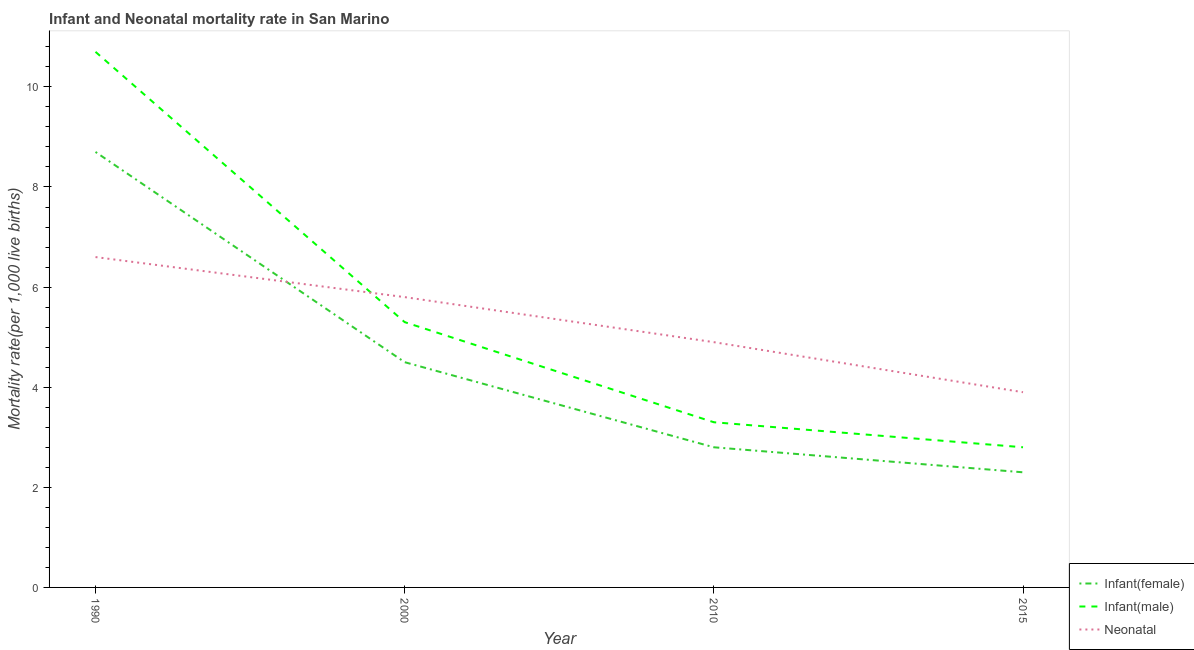What is the neonatal mortality rate in 2015?
Offer a very short reply. 3.9. Across all years, what is the minimum infant mortality rate(female)?
Provide a succinct answer. 2.3. In which year was the neonatal mortality rate maximum?
Make the answer very short. 1990. In which year was the infant mortality rate(male) minimum?
Provide a succinct answer. 2015. What is the total infant mortality rate(female) in the graph?
Provide a short and direct response. 18.3. What is the difference between the neonatal mortality rate in 1990 and that in 2000?
Provide a short and direct response. 0.8. What is the difference between the infant mortality rate(male) in 2015 and the neonatal mortality rate in 2000?
Your answer should be compact. -3. What is the average neonatal mortality rate per year?
Offer a terse response. 5.3. In the year 2000, what is the difference between the infant mortality rate(male) and infant mortality rate(female)?
Provide a succinct answer. 0.8. In how many years, is the infant mortality rate(female) greater than 8?
Your answer should be very brief. 1. What is the ratio of the infant mortality rate(male) in 2010 to that in 2015?
Offer a very short reply. 1.18. Is the infant mortality rate(female) in 1990 less than that in 2000?
Your answer should be compact. No. Is the difference between the infant mortality rate(female) in 1990 and 2000 greater than the difference between the neonatal mortality rate in 1990 and 2000?
Keep it short and to the point. Yes. What is the difference between the highest and the second highest infant mortality rate(female)?
Your answer should be very brief. 4.2. What is the difference between the highest and the lowest infant mortality rate(female)?
Ensure brevity in your answer.  6.4. Does the neonatal mortality rate monotonically increase over the years?
Your response must be concise. No. Is the neonatal mortality rate strictly greater than the infant mortality rate(male) over the years?
Your answer should be compact. No. How many lines are there?
Make the answer very short. 3. Does the graph contain grids?
Your answer should be very brief. No. Where does the legend appear in the graph?
Give a very brief answer. Bottom right. How many legend labels are there?
Make the answer very short. 3. What is the title of the graph?
Offer a very short reply. Infant and Neonatal mortality rate in San Marino. Does "Central government" appear as one of the legend labels in the graph?
Offer a terse response. No. What is the label or title of the Y-axis?
Provide a short and direct response. Mortality rate(per 1,0 live births). What is the Mortality rate(per 1,000 live births) of Infant(female) in 1990?
Provide a succinct answer. 8.7. What is the Mortality rate(per 1,000 live births) of Infant(female) in 2010?
Your response must be concise. 2.8. What is the Mortality rate(per 1,000 live births) in Infant(male) in 2010?
Provide a short and direct response. 3.3. What is the Mortality rate(per 1,000 live births) of Neonatal  in 2010?
Offer a terse response. 4.9. What is the Mortality rate(per 1,000 live births) in Infant(female) in 2015?
Ensure brevity in your answer.  2.3. What is the Mortality rate(per 1,000 live births) in Infant(male) in 2015?
Provide a short and direct response. 2.8. Across all years, what is the maximum Mortality rate(per 1,000 live births) of Infant(male)?
Ensure brevity in your answer.  10.7. Across all years, what is the maximum Mortality rate(per 1,000 live births) of Neonatal ?
Offer a very short reply. 6.6. Across all years, what is the minimum Mortality rate(per 1,000 live births) in Infant(female)?
Give a very brief answer. 2.3. Across all years, what is the minimum Mortality rate(per 1,000 live births) in Infant(male)?
Your response must be concise. 2.8. What is the total Mortality rate(per 1,000 live births) in Infant(female) in the graph?
Your answer should be compact. 18.3. What is the total Mortality rate(per 1,000 live births) in Infant(male) in the graph?
Give a very brief answer. 22.1. What is the total Mortality rate(per 1,000 live births) in Neonatal  in the graph?
Ensure brevity in your answer.  21.2. What is the difference between the Mortality rate(per 1,000 live births) of Infant(female) in 1990 and that in 2000?
Your answer should be compact. 4.2. What is the difference between the Mortality rate(per 1,000 live births) of Infant(female) in 1990 and that in 2010?
Your response must be concise. 5.9. What is the difference between the Mortality rate(per 1,000 live births) of Neonatal  in 1990 and that in 2010?
Keep it short and to the point. 1.7. What is the difference between the Mortality rate(per 1,000 live births) of Infant(male) in 1990 and that in 2015?
Ensure brevity in your answer.  7.9. What is the difference between the Mortality rate(per 1,000 live births) of Infant(female) in 2000 and that in 2010?
Your answer should be compact. 1.7. What is the difference between the Mortality rate(per 1,000 live births) in Infant(male) in 2000 and that in 2010?
Keep it short and to the point. 2. What is the difference between the Mortality rate(per 1,000 live births) in Infant(female) in 2010 and that in 2015?
Provide a short and direct response. 0.5. What is the difference between the Mortality rate(per 1,000 live births) of Infant(male) in 2010 and that in 2015?
Make the answer very short. 0.5. What is the difference between the Mortality rate(per 1,000 live births) of Neonatal  in 2010 and that in 2015?
Make the answer very short. 1. What is the difference between the Mortality rate(per 1,000 live births) in Infant(female) in 1990 and the Mortality rate(per 1,000 live births) in Infant(male) in 2000?
Keep it short and to the point. 3.4. What is the difference between the Mortality rate(per 1,000 live births) in Infant(female) in 1990 and the Mortality rate(per 1,000 live births) in Infant(male) in 2010?
Provide a succinct answer. 5.4. What is the difference between the Mortality rate(per 1,000 live births) of Infant(female) in 1990 and the Mortality rate(per 1,000 live births) of Infant(male) in 2015?
Your response must be concise. 5.9. What is the difference between the Mortality rate(per 1,000 live births) of Infant(male) in 1990 and the Mortality rate(per 1,000 live births) of Neonatal  in 2015?
Offer a terse response. 6.8. What is the difference between the Mortality rate(per 1,000 live births) in Infant(female) in 2000 and the Mortality rate(per 1,000 live births) in Infant(male) in 2010?
Give a very brief answer. 1.2. What is the difference between the Mortality rate(per 1,000 live births) in Infant(female) in 2000 and the Mortality rate(per 1,000 live births) in Neonatal  in 2010?
Provide a succinct answer. -0.4. What is the difference between the Mortality rate(per 1,000 live births) in Infant(female) in 2000 and the Mortality rate(per 1,000 live births) in Infant(male) in 2015?
Your response must be concise. 1.7. What is the difference between the Mortality rate(per 1,000 live births) of Infant(male) in 2010 and the Mortality rate(per 1,000 live births) of Neonatal  in 2015?
Offer a terse response. -0.6. What is the average Mortality rate(per 1,000 live births) in Infant(female) per year?
Your response must be concise. 4.58. What is the average Mortality rate(per 1,000 live births) in Infant(male) per year?
Keep it short and to the point. 5.53. What is the average Mortality rate(per 1,000 live births) of Neonatal  per year?
Your response must be concise. 5.3. In the year 2000, what is the difference between the Mortality rate(per 1,000 live births) in Infant(female) and Mortality rate(per 1,000 live births) in Neonatal ?
Ensure brevity in your answer.  -1.3. In the year 2010, what is the difference between the Mortality rate(per 1,000 live births) in Infant(female) and Mortality rate(per 1,000 live births) in Infant(male)?
Make the answer very short. -0.5. In the year 2010, what is the difference between the Mortality rate(per 1,000 live births) in Infant(male) and Mortality rate(per 1,000 live births) in Neonatal ?
Provide a short and direct response. -1.6. In the year 2015, what is the difference between the Mortality rate(per 1,000 live births) in Infant(female) and Mortality rate(per 1,000 live births) in Infant(male)?
Offer a terse response. -0.5. In the year 2015, what is the difference between the Mortality rate(per 1,000 live births) in Infant(male) and Mortality rate(per 1,000 live births) in Neonatal ?
Keep it short and to the point. -1.1. What is the ratio of the Mortality rate(per 1,000 live births) of Infant(female) in 1990 to that in 2000?
Provide a short and direct response. 1.93. What is the ratio of the Mortality rate(per 1,000 live births) in Infant(male) in 1990 to that in 2000?
Make the answer very short. 2.02. What is the ratio of the Mortality rate(per 1,000 live births) of Neonatal  in 1990 to that in 2000?
Provide a short and direct response. 1.14. What is the ratio of the Mortality rate(per 1,000 live births) of Infant(female) in 1990 to that in 2010?
Your answer should be very brief. 3.11. What is the ratio of the Mortality rate(per 1,000 live births) of Infant(male) in 1990 to that in 2010?
Provide a short and direct response. 3.24. What is the ratio of the Mortality rate(per 1,000 live births) in Neonatal  in 1990 to that in 2010?
Your answer should be compact. 1.35. What is the ratio of the Mortality rate(per 1,000 live births) in Infant(female) in 1990 to that in 2015?
Your answer should be compact. 3.78. What is the ratio of the Mortality rate(per 1,000 live births) of Infant(male) in 1990 to that in 2015?
Make the answer very short. 3.82. What is the ratio of the Mortality rate(per 1,000 live births) of Neonatal  in 1990 to that in 2015?
Provide a short and direct response. 1.69. What is the ratio of the Mortality rate(per 1,000 live births) of Infant(female) in 2000 to that in 2010?
Give a very brief answer. 1.61. What is the ratio of the Mortality rate(per 1,000 live births) of Infant(male) in 2000 to that in 2010?
Make the answer very short. 1.61. What is the ratio of the Mortality rate(per 1,000 live births) in Neonatal  in 2000 to that in 2010?
Give a very brief answer. 1.18. What is the ratio of the Mortality rate(per 1,000 live births) of Infant(female) in 2000 to that in 2015?
Your answer should be very brief. 1.96. What is the ratio of the Mortality rate(per 1,000 live births) in Infant(male) in 2000 to that in 2015?
Provide a succinct answer. 1.89. What is the ratio of the Mortality rate(per 1,000 live births) of Neonatal  in 2000 to that in 2015?
Offer a terse response. 1.49. What is the ratio of the Mortality rate(per 1,000 live births) in Infant(female) in 2010 to that in 2015?
Keep it short and to the point. 1.22. What is the ratio of the Mortality rate(per 1,000 live births) of Infant(male) in 2010 to that in 2015?
Offer a terse response. 1.18. What is the ratio of the Mortality rate(per 1,000 live births) in Neonatal  in 2010 to that in 2015?
Ensure brevity in your answer.  1.26. What is the difference between the highest and the lowest Mortality rate(per 1,000 live births) in Infant(male)?
Offer a very short reply. 7.9. What is the difference between the highest and the lowest Mortality rate(per 1,000 live births) in Neonatal ?
Offer a terse response. 2.7. 